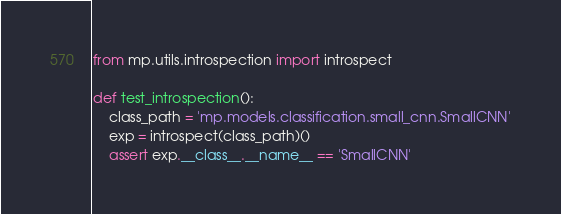Convert code to text. <code><loc_0><loc_0><loc_500><loc_500><_Python_>from mp.utils.introspection import introspect

def test_introspection():
    class_path = 'mp.models.classification.small_cnn.SmallCNN'
    exp = introspect(class_path)()
    assert exp.__class__.__name__ == 'SmallCNN'</code> 